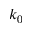Convert formula to latex. <formula><loc_0><loc_0><loc_500><loc_500>k _ { 0 }</formula> 